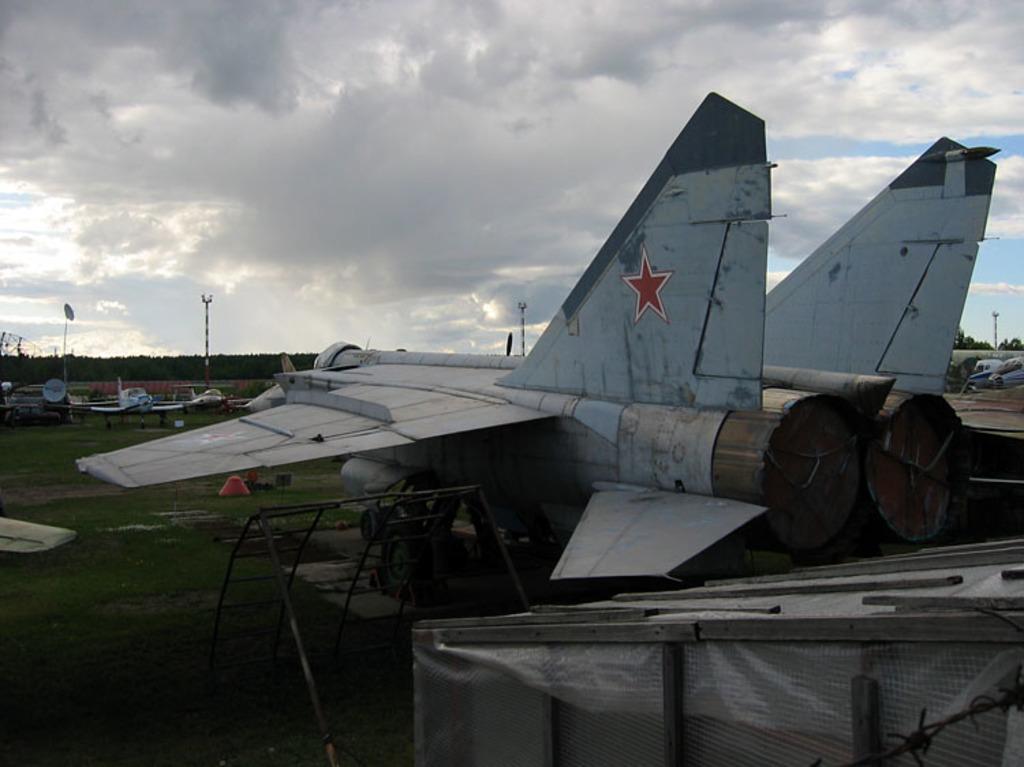Could you give a brief overview of what you see in this image? There are flights. Near to the flights there are ladders. On the ground there is grass. In the background there is sky with clouds. Also there are trees. 